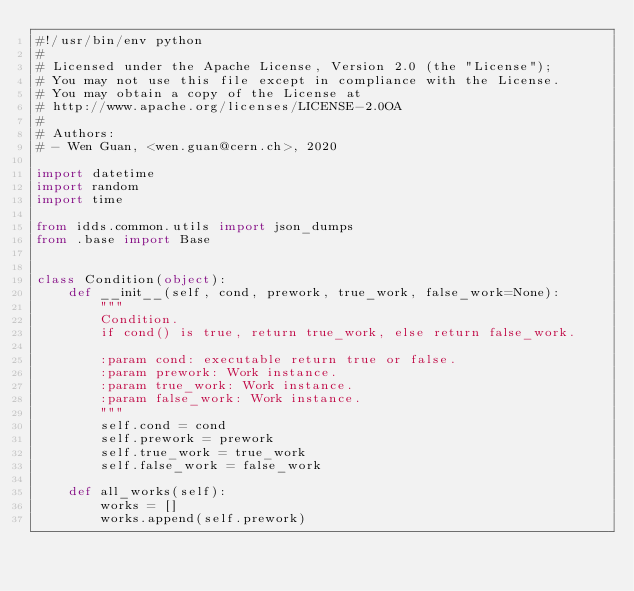Convert code to text. <code><loc_0><loc_0><loc_500><loc_500><_Python_>#!/usr/bin/env python
#
# Licensed under the Apache License, Version 2.0 (the "License");
# You may not use this file except in compliance with the License.
# You may obtain a copy of the License at
# http://www.apache.org/licenses/LICENSE-2.0OA
#
# Authors:
# - Wen Guan, <wen.guan@cern.ch>, 2020

import datetime
import random
import time

from idds.common.utils import json_dumps
from .base import Base


class Condition(object):
    def __init__(self, cond, prework, true_work, false_work=None):
        """
        Condition.
        if cond() is true, return true_work, else return false_work.

        :param cond: executable return true or false.
        :param prework: Work instance.
        :param true_work: Work instance.
        :param false_work: Work instance.
        """
        self.cond = cond
        self.prework = prework
        self.true_work = true_work
        self.false_work = false_work

    def all_works(self):
        works = []
        works.append(self.prework)</code> 